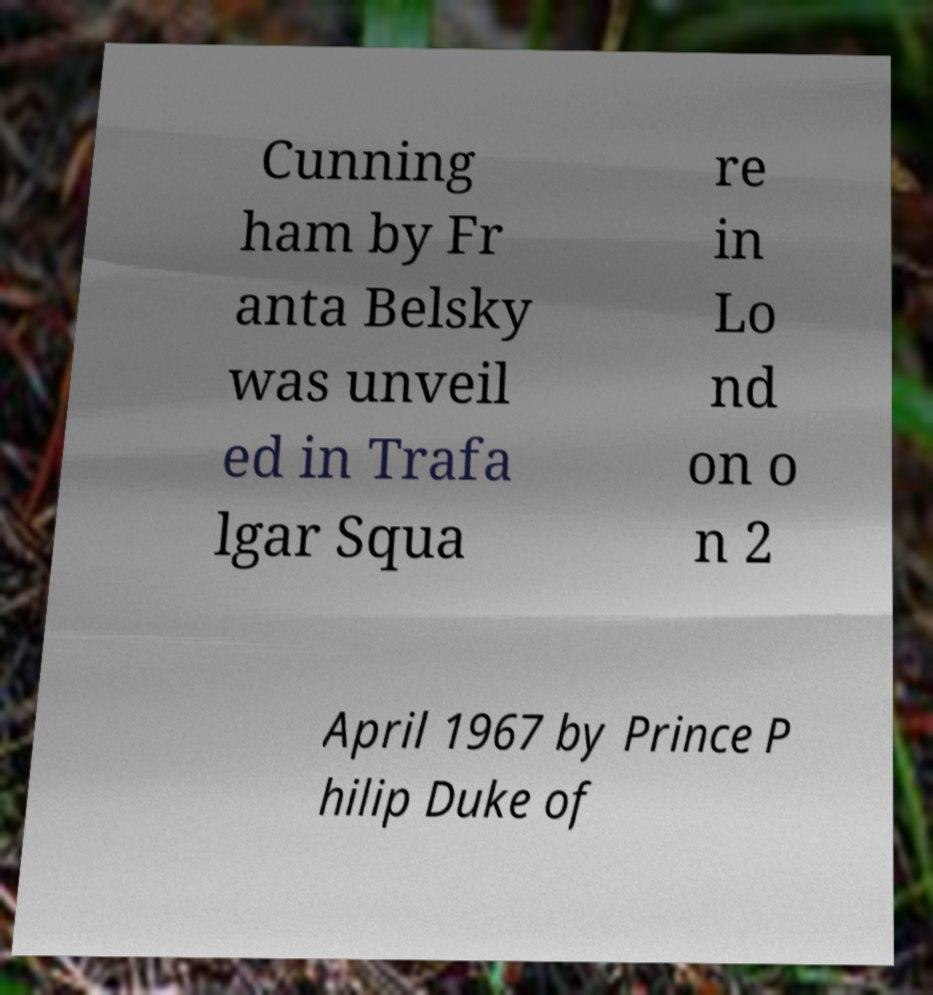Please identify and transcribe the text found in this image. Cunning ham by Fr anta Belsky was unveil ed in Trafa lgar Squa re in Lo nd on o n 2 April 1967 by Prince P hilip Duke of 